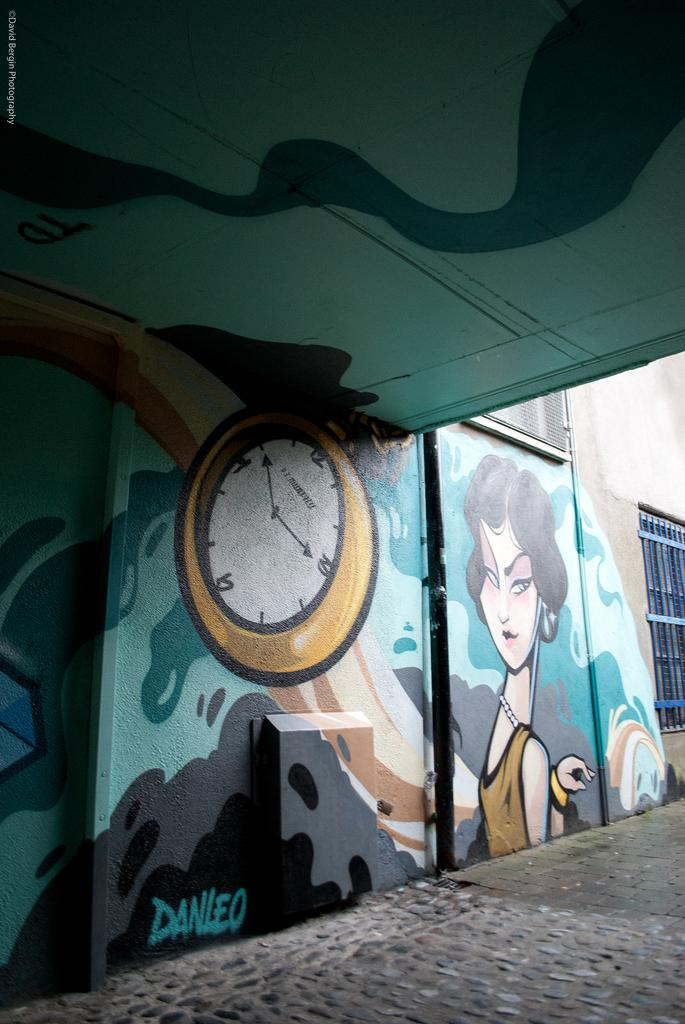What type of structure is present in the image? There is a building in the image. Can you describe any decorations or markings on the building? Yes, there is graffiti on the roof and wall of the building. What can be seen below the building in the image? The ground is visible in the image. What type of form does the earth take in the image? The image does not depict the earth; it shows a building with graffiti and the ground below it. What material is the brick used for the building in the image? The image does not specify the material used for the building; it only shows the presence of graffiti on the roof and wall. 